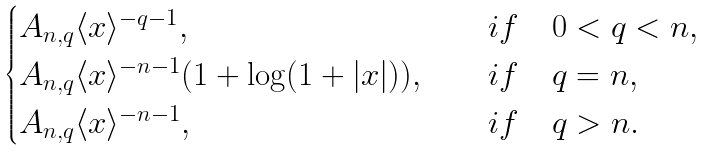<formula> <loc_0><loc_0><loc_500><loc_500>\begin{cases} A _ { n , q } \langle x \rangle ^ { - q - 1 } , & \quad i f \quad 0 < q < n , \\ A _ { n , q } \langle x \rangle ^ { - n - 1 } ( 1 + \log ( 1 + | x | ) ) , & \quad i f \quad q = n , \\ A _ { n , q } \langle x \rangle ^ { - n - 1 } , & \quad i f \quad q > n . \end{cases}</formula> 